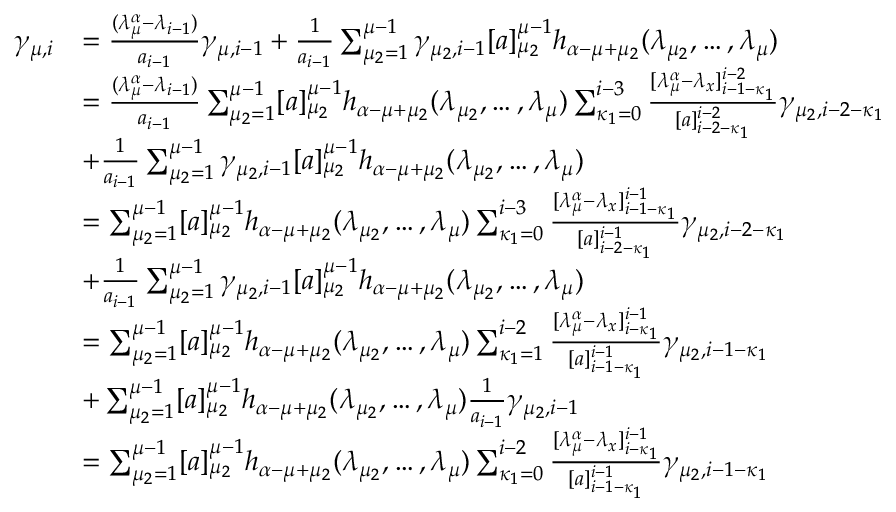<formula> <loc_0><loc_0><loc_500><loc_500>\begin{array} { r l } { \gamma _ { \mu , i } } & { = \frac { ( \lambda _ { \mu } ^ { \alpha } - \lambda _ { i - 1 } ) } { a _ { i - 1 } } \gamma _ { \mu , i - 1 } + \frac { 1 } { a _ { i - 1 } } \sum _ { \mu _ { 2 } = 1 } ^ { \mu - 1 } \gamma _ { \mu _ { 2 } , i - 1 } [ a ] _ { \mu _ { 2 } } ^ { \mu - 1 } h _ { \alpha - \mu + \mu _ { 2 } } ( \lambda _ { \mu _ { 2 } } , \dots , \lambda _ { \mu } ) } \\ & { = \frac { ( \lambda _ { \mu } ^ { \alpha } - \lambda _ { i - 1 } ) } { a _ { i - 1 } } \sum _ { \mu _ { 2 } = 1 } ^ { \mu - 1 } [ a ] _ { \mu _ { 2 } } ^ { \mu - 1 } h _ { \alpha - \mu + \mu _ { 2 } } ( \lambda _ { \mu _ { 2 } } , \dots , \lambda _ { \mu } ) \sum _ { \kappa _ { 1 } = 0 } ^ { i - 3 } \frac { [ \lambda _ { \mu } ^ { \alpha } - \lambda _ { x } ] _ { i - 1 - \kappa _ { 1 } } ^ { i - 2 } } { [ a ] _ { i - 2 - \kappa _ { 1 } } ^ { i - 2 } } \gamma _ { \mu _ { 2 } , i - 2 - \kappa _ { 1 } } } \\ & { + \frac { 1 } { a _ { i - 1 } } \sum _ { \mu _ { 2 } = 1 } ^ { \mu - 1 } \gamma _ { \mu _ { 2 } , i - 1 } [ a ] _ { \mu _ { 2 } } ^ { \mu - 1 } h _ { \alpha - \mu + \mu _ { 2 } } ( \lambda _ { \mu _ { 2 } } , \dots , \lambda _ { \mu } ) } \\ & { = \sum _ { \mu _ { 2 } = 1 } ^ { \mu - 1 } [ a ] _ { \mu _ { 2 } } ^ { \mu - 1 } h _ { \alpha - \mu + \mu _ { 2 } } ( \lambda _ { \mu _ { 2 } } , \dots , \lambda _ { \mu } ) \sum _ { \kappa _ { 1 } = 0 } ^ { i - 3 } \frac { [ \lambda _ { \mu } ^ { \alpha } - \lambda _ { x } ] _ { i - 1 - \kappa _ { 1 } } ^ { i - 1 } } { [ a ] _ { i - 2 - \kappa _ { 1 } } ^ { i - 1 } } \gamma _ { \mu _ { 2 } , i - 2 - \kappa _ { 1 } } } \\ & { + \frac { 1 } { a _ { i - 1 } } \sum _ { \mu _ { 2 } = 1 } ^ { \mu - 1 } \gamma _ { \mu _ { 2 } , i - 1 } [ a ] _ { \mu _ { 2 } } ^ { \mu - 1 } h _ { \alpha - \mu + \mu _ { 2 } } ( \lambda _ { \mu _ { 2 } } , \dots , \lambda _ { \mu } ) } \\ & { = \sum _ { \mu _ { 2 } = 1 } ^ { \mu - 1 } [ a ] _ { \mu _ { 2 } } ^ { \mu - 1 } h _ { \alpha - \mu + \mu _ { 2 } } ( \lambda _ { \mu _ { 2 } } , \dots , \lambda _ { \mu } ) \sum _ { \kappa _ { 1 } = 1 } ^ { i - 2 } \frac { [ \lambda _ { \mu } ^ { \alpha } - \lambda _ { x } ] _ { i - \kappa _ { 1 } } ^ { i - 1 } } { [ a ] _ { i - 1 - \kappa _ { 1 } } ^ { i - 1 } } \gamma _ { \mu _ { 2 } , i - 1 - \kappa _ { 1 } } } \\ & { + \sum _ { \mu _ { 2 } = 1 } ^ { \mu - 1 } [ a ] _ { \mu _ { 2 } } ^ { \mu - 1 } h _ { \alpha - \mu + \mu _ { 2 } } ( \lambda _ { \mu _ { 2 } } , \dots , \lambda _ { \mu } ) \frac { 1 } { a _ { i - 1 } } \gamma _ { \mu _ { 2 } , i - 1 } } \\ & { = \sum _ { \mu _ { 2 } = 1 } ^ { \mu - 1 } [ a ] _ { \mu _ { 2 } } ^ { \mu - 1 } h _ { \alpha - \mu + \mu _ { 2 } } ( \lambda _ { \mu _ { 2 } } , \dots , \lambda _ { \mu } ) \sum _ { \kappa _ { 1 } = 0 } ^ { i - 2 } \frac { [ \lambda _ { \mu } ^ { \alpha } - \lambda _ { x } ] _ { i - \kappa _ { 1 } } ^ { i - 1 } } { [ a ] _ { i - 1 - \kappa _ { 1 } } ^ { i - 1 } } \gamma _ { \mu _ { 2 } , i - 1 - \kappa _ { 1 } } } \end{array}</formula> 